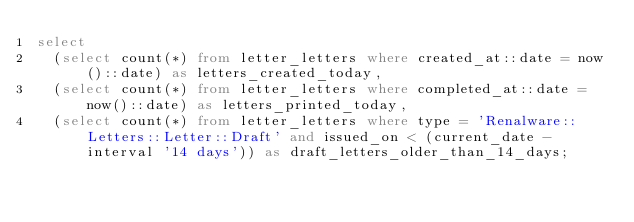<code> <loc_0><loc_0><loc_500><loc_500><_SQL_>select
  (select count(*) from letter_letters where created_at::date = now()::date) as letters_created_today,
  (select count(*) from letter_letters where completed_at::date = now()::date) as letters_printed_today,
  (select count(*) from letter_letters where type = 'Renalware::Letters::Letter::Draft' and issued_on < (current_date - interval '14 days')) as draft_letters_older_than_14_days;
</code> 